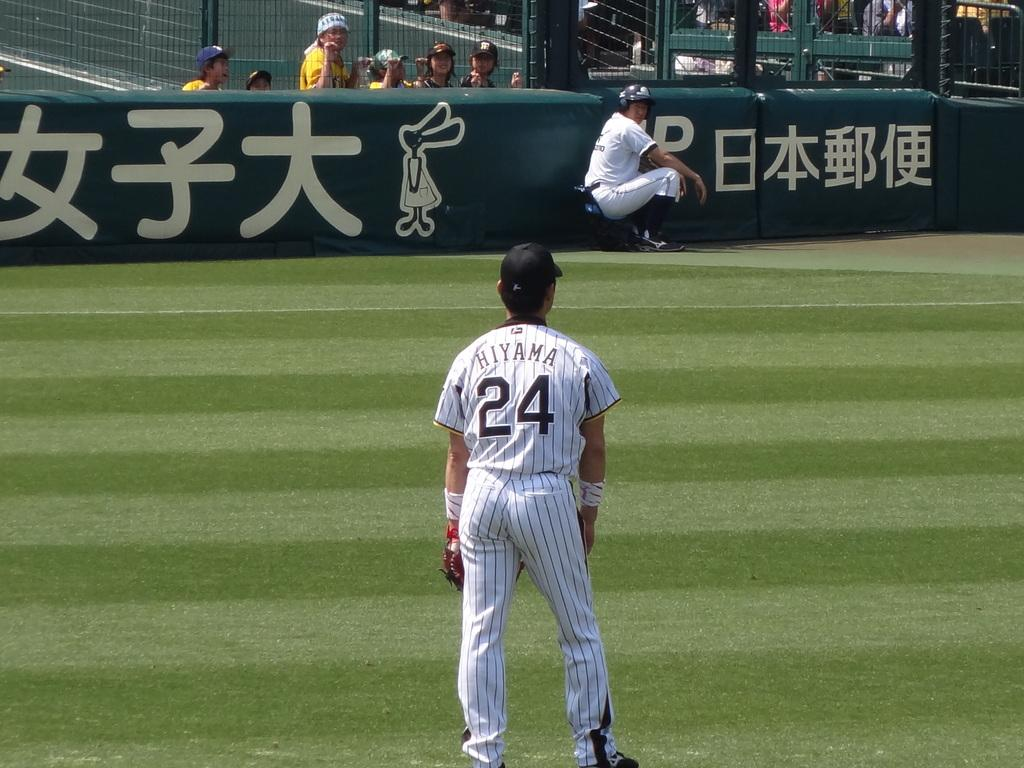<image>
Describe the image concisely. Hiyama # 24 is in the outfield of a baseball game looking at his catcher. 